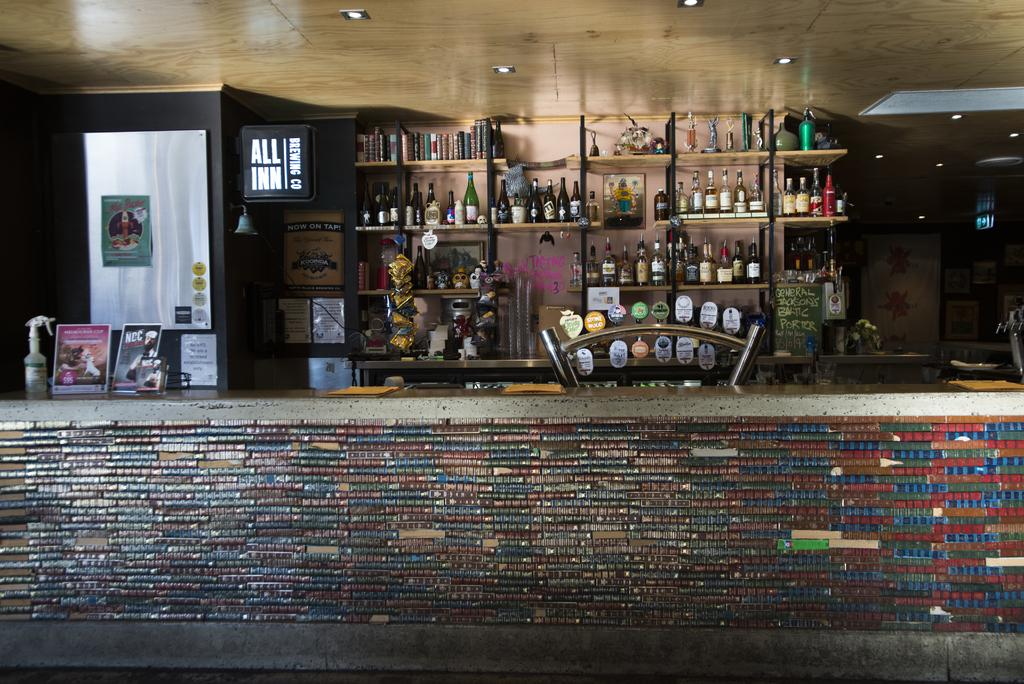What can be seen in the background of the image? There is a wall in the image. What is placed on the wall? There are bottles on shelves in the image. What type of decorations are present in the image? There are posters in the image. What provides illumination in the image? There are lights in the image. What is above the objects and people in the image? There is a ceiling in the image. Can you describe the unspecified objects in the image? Unfortunately, the provided facts do not specify the nature of these objects. How many balls are visible in the image? There are no balls present in the image. What is the mass of the wall in the image? The mass of the wall cannot be determined from the image alone. 